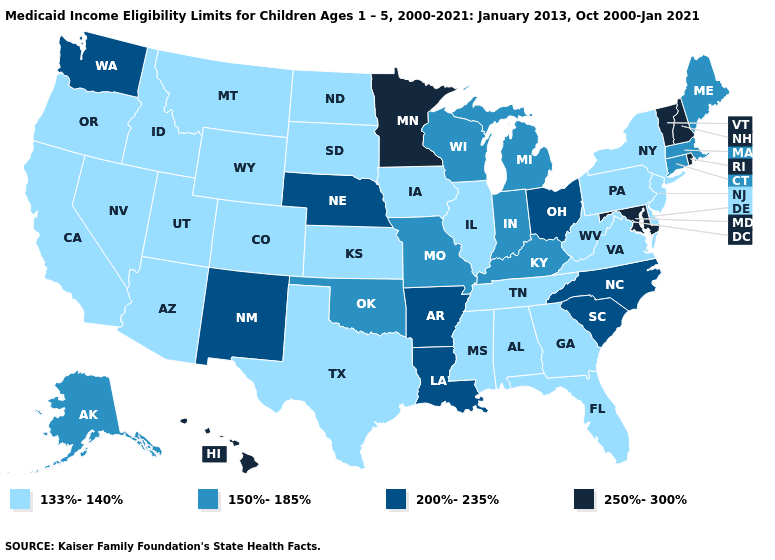Name the states that have a value in the range 133%-140%?
Keep it brief. Alabama, Arizona, California, Colorado, Delaware, Florida, Georgia, Idaho, Illinois, Iowa, Kansas, Mississippi, Montana, Nevada, New Jersey, New York, North Dakota, Oregon, Pennsylvania, South Dakota, Tennessee, Texas, Utah, Virginia, West Virginia, Wyoming. What is the value of Iowa?
Quick response, please. 133%-140%. Name the states that have a value in the range 150%-185%?
Write a very short answer. Alaska, Connecticut, Indiana, Kentucky, Maine, Massachusetts, Michigan, Missouri, Oklahoma, Wisconsin. What is the value of Kentucky?
Give a very brief answer. 150%-185%. What is the value of Vermont?
Keep it brief. 250%-300%. Among the states that border New York , does Massachusetts have the lowest value?
Quick response, please. No. What is the value of Oregon?
Give a very brief answer. 133%-140%. Among the states that border Colorado , which have the lowest value?
Short answer required. Arizona, Kansas, Utah, Wyoming. Does Connecticut have the same value as Colorado?
Quick response, please. No. Name the states that have a value in the range 150%-185%?
Concise answer only. Alaska, Connecticut, Indiana, Kentucky, Maine, Massachusetts, Michigan, Missouri, Oklahoma, Wisconsin. What is the highest value in the USA?
Answer briefly. 250%-300%. Name the states that have a value in the range 150%-185%?
Give a very brief answer. Alaska, Connecticut, Indiana, Kentucky, Maine, Massachusetts, Michigan, Missouri, Oklahoma, Wisconsin. Name the states that have a value in the range 200%-235%?
Keep it brief. Arkansas, Louisiana, Nebraska, New Mexico, North Carolina, Ohio, South Carolina, Washington. What is the value of Florida?
Concise answer only. 133%-140%. Does the first symbol in the legend represent the smallest category?
Write a very short answer. Yes. 